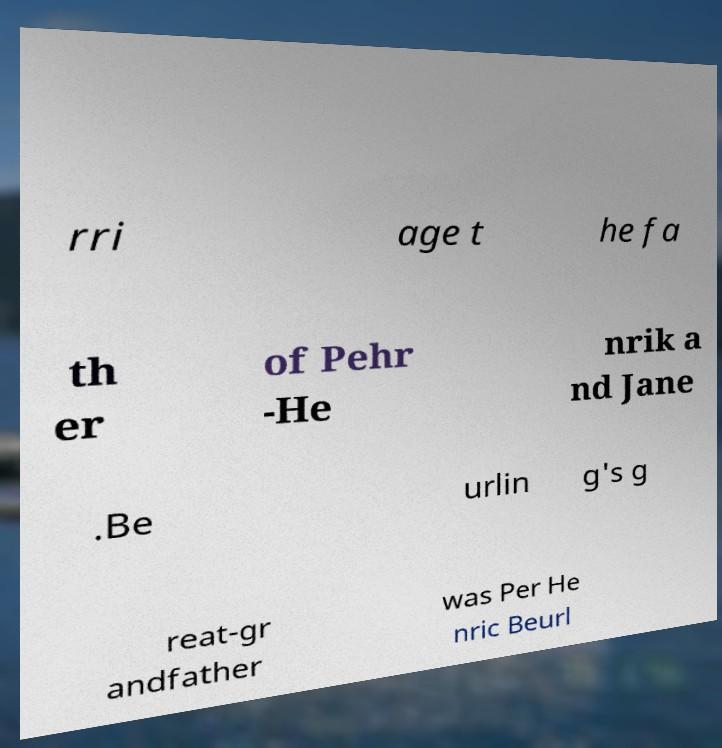Please identify and transcribe the text found in this image. rri age t he fa th er of Pehr -He nrik a nd Jane .Be urlin g's g reat-gr andfather was Per He nric Beurl 